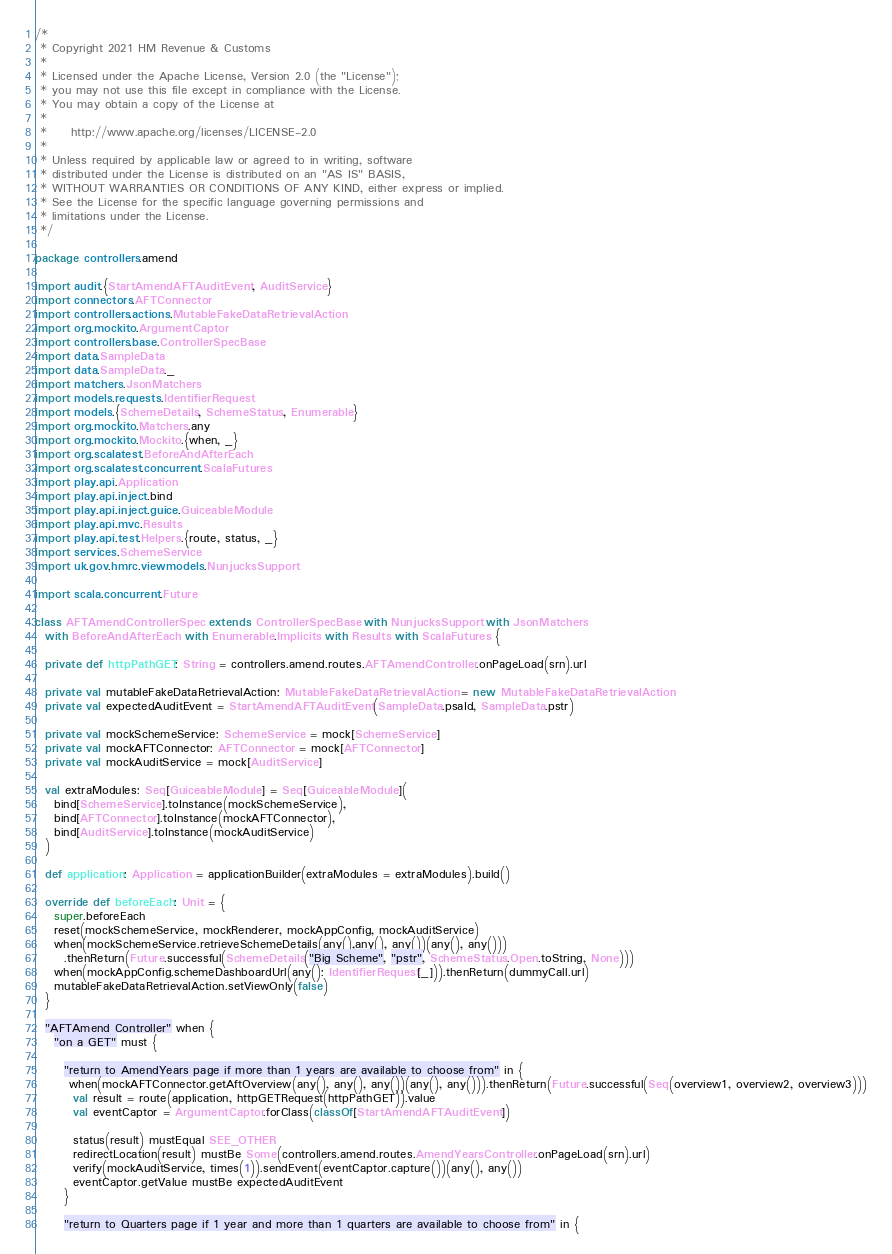<code> <loc_0><loc_0><loc_500><loc_500><_Scala_>/*
 * Copyright 2021 HM Revenue & Customs
 *
 * Licensed under the Apache License, Version 2.0 (the "License");
 * you may not use this file except in compliance with the License.
 * You may obtain a copy of the License at
 *
 *     http://www.apache.org/licenses/LICENSE-2.0
 *
 * Unless required by applicable law or agreed to in writing, software
 * distributed under the License is distributed on an "AS IS" BASIS,
 * WITHOUT WARRANTIES OR CONDITIONS OF ANY KIND, either express or implied.
 * See the License for the specific language governing permissions and
 * limitations under the License.
 */

package controllers.amend

import audit.{StartAmendAFTAuditEvent, AuditService}
import connectors.AFTConnector
import controllers.actions.MutableFakeDataRetrievalAction
import org.mockito.ArgumentCaptor
import controllers.base.ControllerSpecBase
import data.SampleData
import data.SampleData._
import matchers.JsonMatchers
import models.requests.IdentifierRequest
import models.{SchemeDetails, SchemeStatus, Enumerable}
import org.mockito.Matchers.any
import org.mockito.Mockito.{when, _}
import org.scalatest.BeforeAndAfterEach
import org.scalatest.concurrent.ScalaFutures
import play.api.Application
import play.api.inject.bind
import play.api.inject.guice.GuiceableModule
import play.api.mvc.Results
import play.api.test.Helpers.{route, status, _}
import services.SchemeService
import uk.gov.hmrc.viewmodels.NunjucksSupport

import scala.concurrent.Future

class AFTAmendControllerSpec extends ControllerSpecBase with NunjucksSupport with JsonMatchers
  with BeforeAndAfterEach with Enumerable.Implicits with Results with ScalaFutures {

  private def httpPathGET: String = controllers.amend.routes.AFTAmendController.onPageLoad(srn).url

  private val mutableFakeDataRetrievalAction: MutableFakeDataRetrievalAction = new MutableFakeDataRetrievalAction
  private val expectedAuditEvent = StartAmendAFTAuditEvent(SampleData.psaId, SampleData.pstr)

  private val mockSchemeService: SchemeService = mock[SchemeService]
  private val mockAFTConnector: AFTConnector = mock[AFTConnector]
  private val mockAuditService = mock[AuditService]

  val extraModules: Seq[GuiceableModule] = Seq[GuiceableModule](
    bind[SchemeService].toInstance(mockSchemeService),
    bind[AFTConnector].toInstance(mockAFTConnector),
    bind[AuditService].toInstance(mockAuditService)
  )

  def application: Application = applicationBuilder(extraModules = extraModules).build()

  override def beforeEach: Unit = {
    super.beforeEach
    reset(mockSchemeService, mockRenderer, mockAppConfig, mockAuditService)
    when(mockSchemeService.retrieveSchemeDetails(any(),any(), any())(any(), any()))
      .thenReturn(Future.successful(SchemeDetails("Big Scheme", "pstr", SchemeStatus.Open.toString, None)))
    when(mockAppConfig.schemeDashboardUrl(any(): IdentifierRequest[_])).thenReturn(dummyCall.url)
    mutableFakeDataRetrievalAction.setViewOnly(false)
  }

  "AFTAmend Controller" when {
    "on a GET" must {

      "return to AmendYears page if more than 1 years are available to choose from" in {
       when(mockAFTConnector.getAftOverview(any(), any(), any())(any(), any())).thenReturn(Future.successful(Seq(overview1, overview2, overview3)))
        val result = route(application, httpGETRequest(httpPathGET)).value
        val eventCaptor = ArgumentCaptor.forClass(classOf[StartAmendAFTAuditEvent])

        status(result) mustEqual SEE_OTHER
        redirectLocation(result) mustBe Some(controllers.amend.routes.AmendYearsController.onPageLoad(srn).url)
        verify(mockAuditService, times(1)).sendEvent(eventCaptor.capture())(any(), any())
        eventCaptor.getValue mustBe expectedAuditEvent
      }

      "return to Quarters page if 1 year and more than 1 quarters are available to choose from" in {</code> 